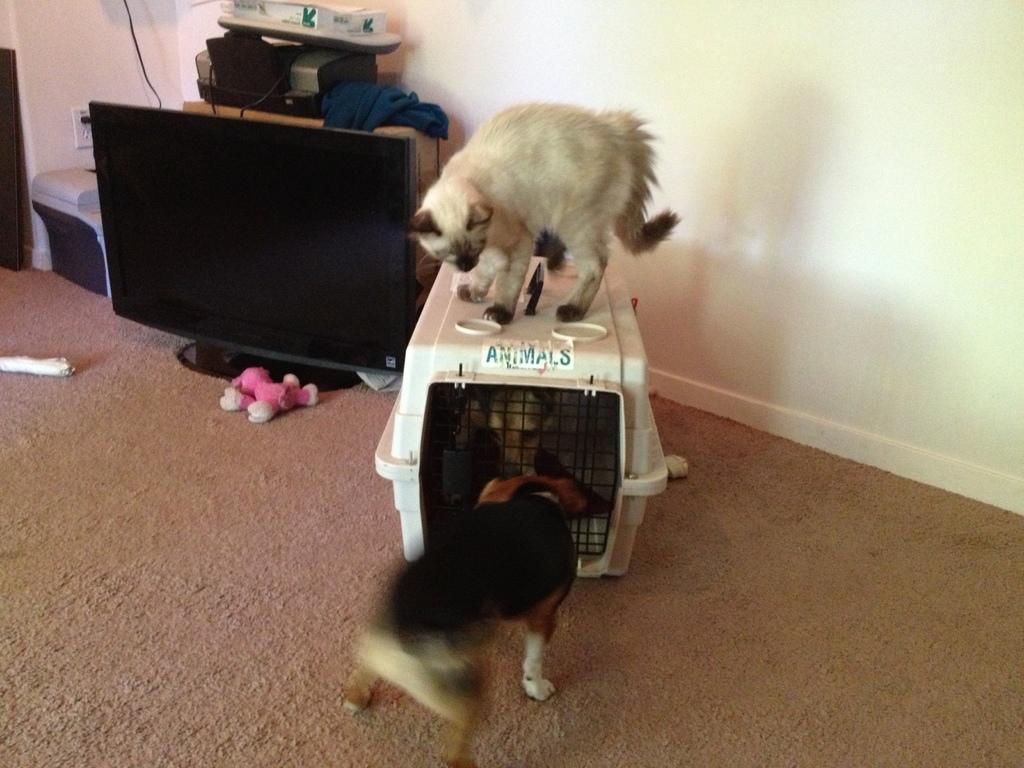Please provide a concise description of this image. In this image, we can see a cat on the dog crate which in front of the wall. There is a dog at the bottom of the image. There is an electrical equipment and monitor in the top left of the image. 